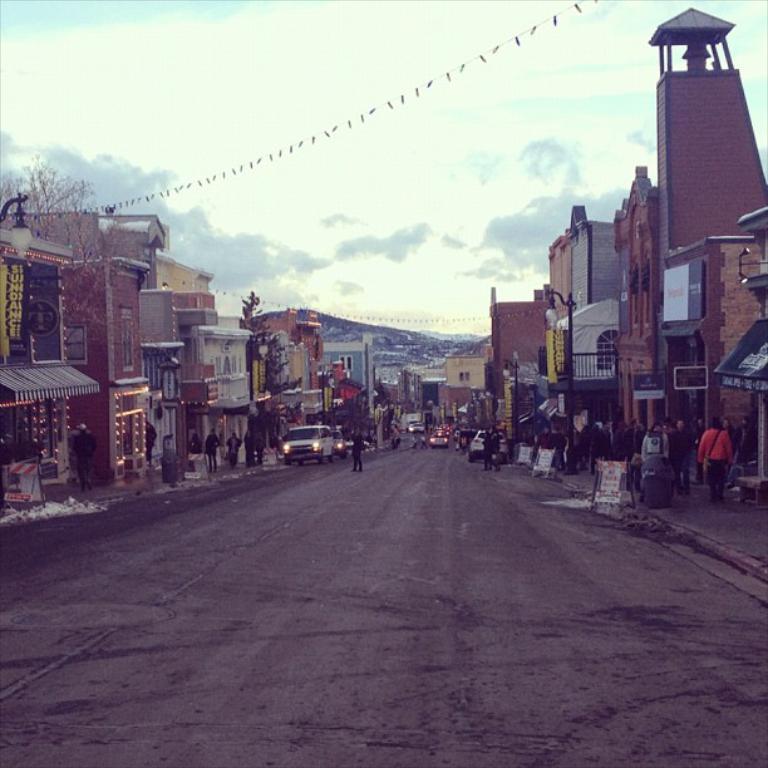Can you describe this image briefly? In the picture I can see the road, vehicles moving on the road, few vehicles are parked at the side of the road and people walking on the sidewalks. Here we can see boards, we can see light poles and buildings on either side of the image. We can see the hill and sky with clouds in the background. 